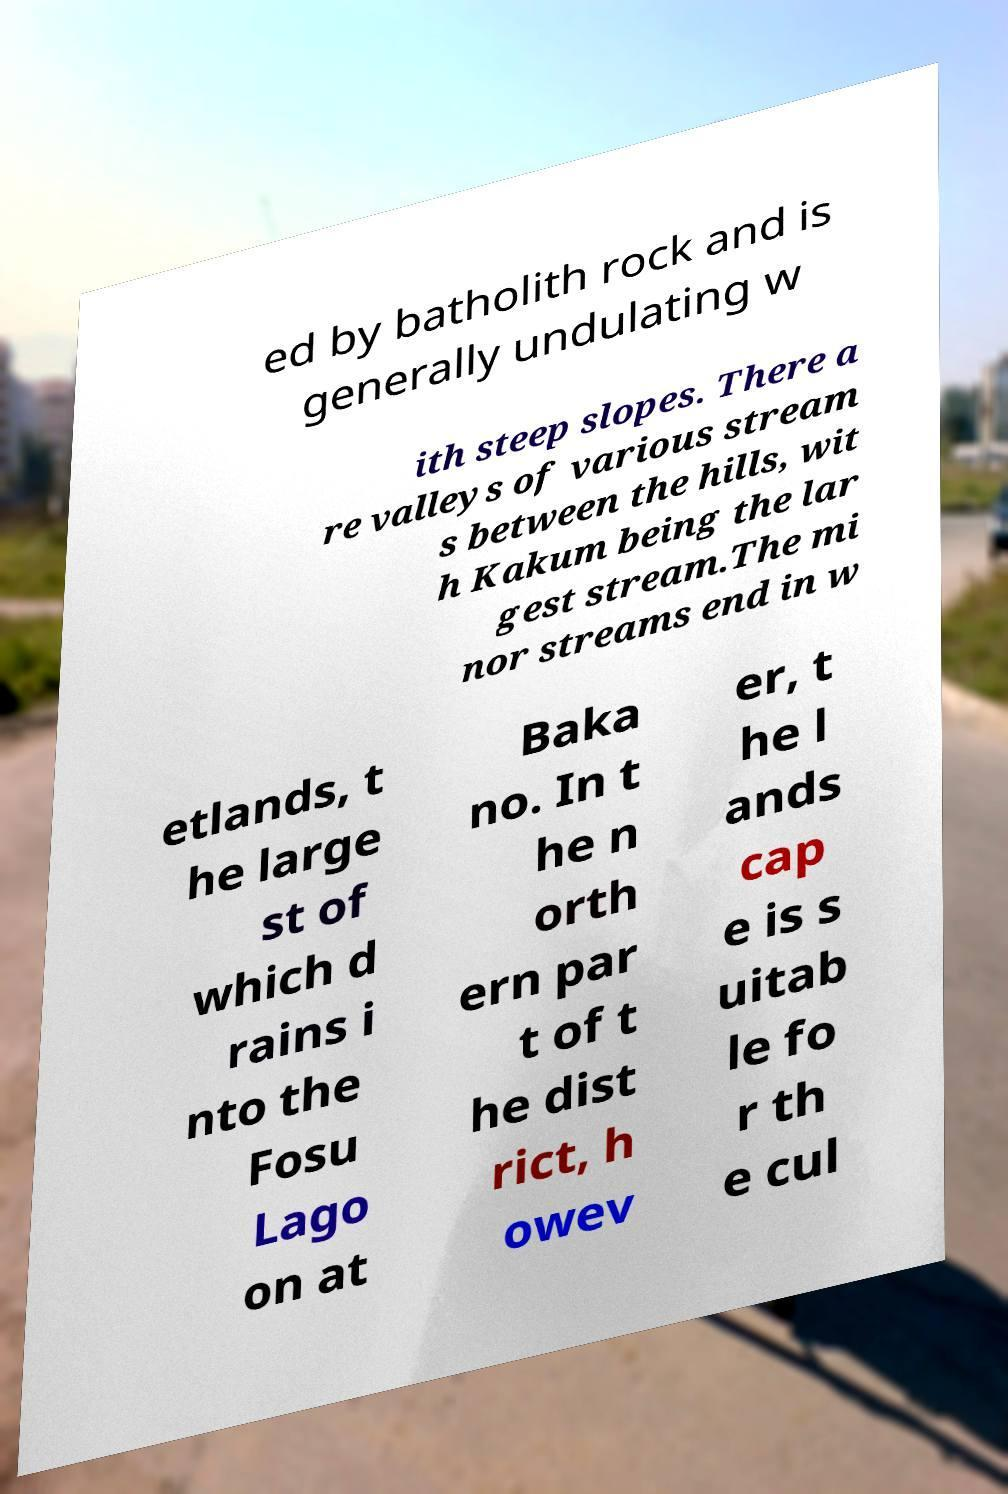Please identify and transcribe the text found in this image. ed by batholith rock and is generally undulating w ith steep slopes. There a re valleys of various stream s between the hills, wit h Kakum being the lar gest stream.The mi nor streams end in w etlands, t he large st of which d rains i nto the Fosu Lago on at Baka no. In t he n orth ern par t of t he dist rict, h owev er, t he l ands cap e is s uitab le fo r th e cul 